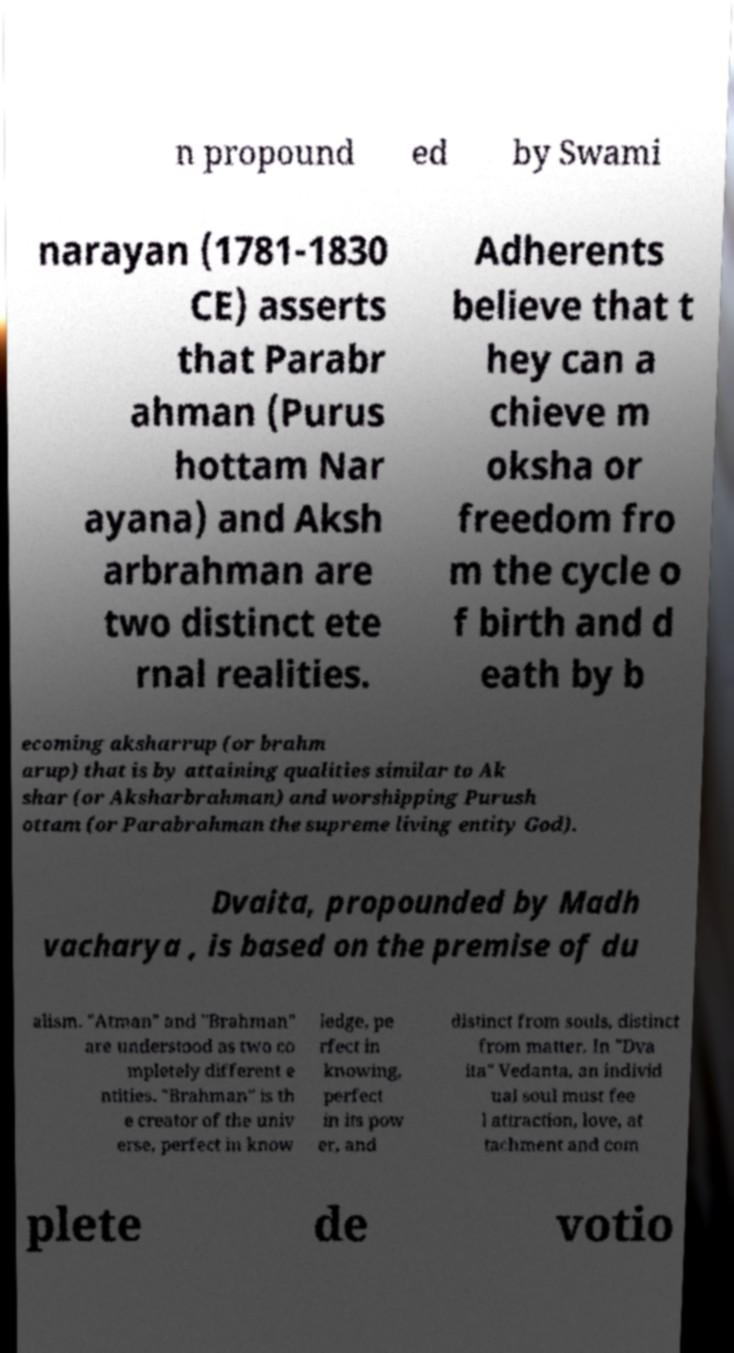Could you extract and type out the text from this image? n propound ed by Swami narayan (1781-1830 CE) asserts that Parabr ahman (Purus hottam Nar ayana) and Aksh arbrahman are two distinct ete rnal realities. Adherents believe that t hey can a chieve m oksha or freedom fro m the cycle o f birth and d eath by b ecoming aksharrup (or brahm arup) that is by attaining qualities similar to Ak shar (or Aksharbrahman) and worshipping Purush ottam (or Parabrahman the supreme living entity God). Dvaita, propounded by Madh vacharya , is based on the premise of du alism. "Atman" and "Brahman" are understood as two co mpletely different e ntities. "Brahman" is th e creator of the univ erse, perfect in know ledge, pe rfect in knowing, perfect in its pow er, and distinct from souls, distinct from matter. In "Dva ita" Vedanta, an individ ual soul must fee l attraction, love, at tachment and com plete de votio 